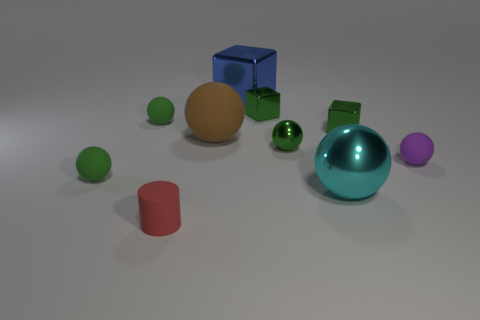Subtract all matte balls. How many balls are left? 2 Subtract all brown balls. How many balls are left? 5 Subtract 1 cylinders. How many cylinders are left? 0 Subtract 1 red cylinders. How many objects are left? 9 Subtract all cylinders. How many objects are left? 9 Subtract all red balls. Subtract all yellow blocks. How many balls are left? 6 Subtract all gray cubes. How many purple spheres are left? 1 Subtract all green cubes. Subtract all blue metal cubes. How many objects are left? 7 Add 3 metallic blocks. How many metallic blocks are left? 6 Add 2 small blue shiny balls. How many small blue shiny balls exist? 2 